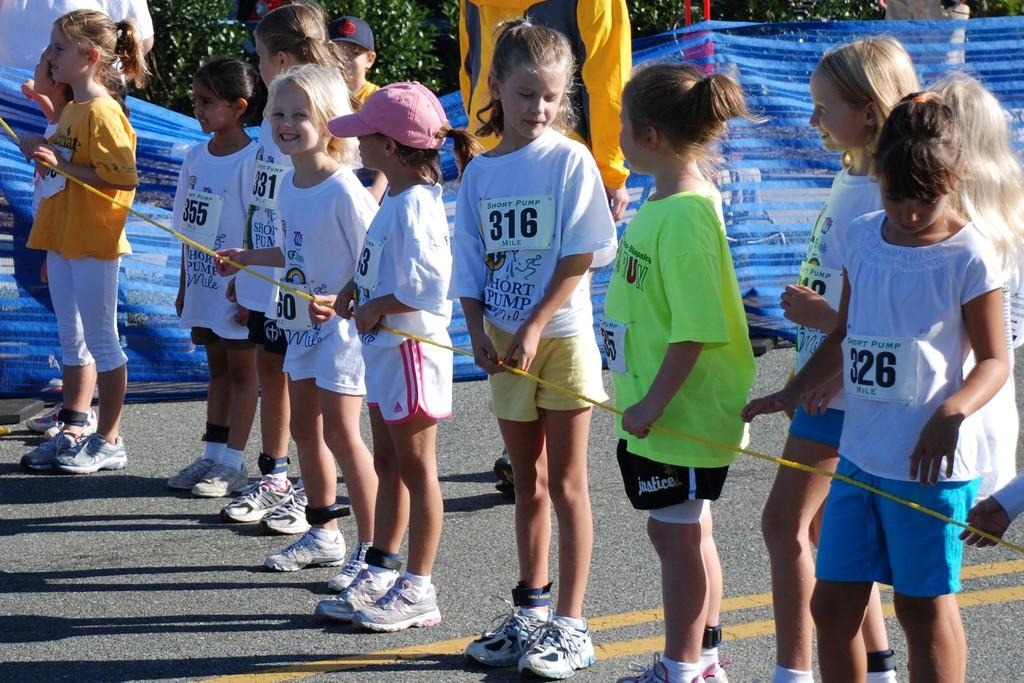Who is present in the image? There are small girls in the image. What are the girls wearing? The girls are wearing white t-shirts. What are the girls holding in the image? The girls are holding a rope. What can be seen in the background of the image? There is a blue color fencing net and trees visible in the background. What type of spoon is being used to stir the kettle in the image? There is no spoon or kettle present in the image. Who is the friend that the girls are talking to in the image? There is no friend visible in the image; it only shows the small girls holding a rope. 